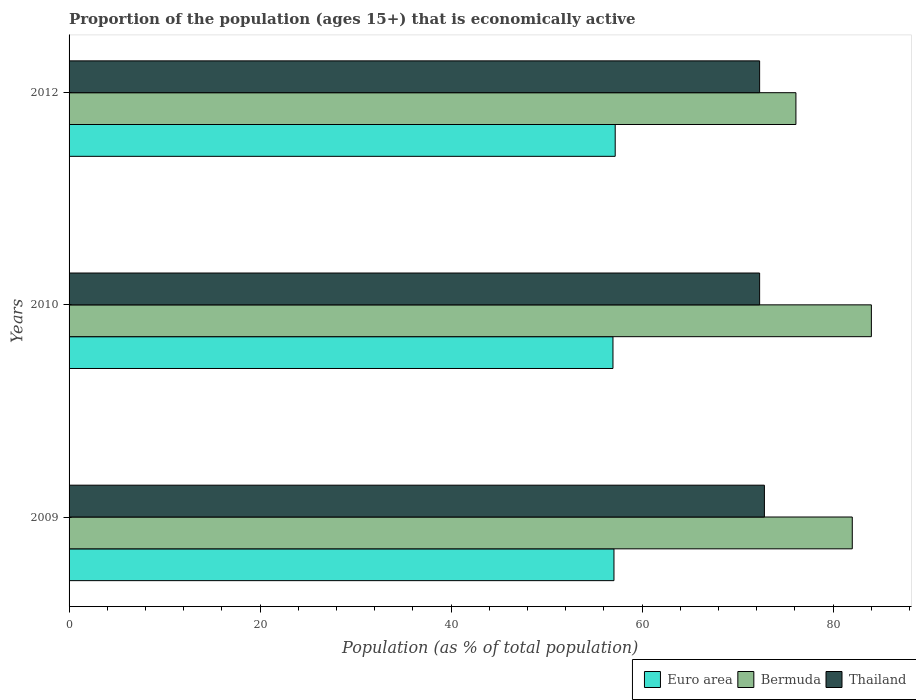Are the number of bars on each tick of the Y-axis equal?
Your response must be concise. Yes. How many bars are there on the 1st tick from the top?
Make the answer very short. 3. In how many cases, is the number of bars for a given year not equal to the number of legend labels?
Provide a succinct answer. 0. What is the proportion of the population that is economically active in Euro area in 2010?
Provide a short and direct response. 56.95. Across all years, what is the maximum proportion of the population that is economically active in Thailand?
Your answer should be compact. 72.8. Across all years, what is the minimum proportion of the population that is economically active in Bermuda?
Keep it short and to the point. 76.1. In which year was the proportion of the population that is economically active in Thailand maximum?
Keep it short and to the point. 2009. In which year was the proportion of the population that is economically active in Thailand minimum?
Your response must be concise. 2010. What is the total proportion of the population that is economically active in Euro area in the graph?
Ensure brevity in your answer.  171.18. What is the difference between the proportion of the population that is economically active in Euro area in 2009 and that in 2010?
Your answer should be very brief. 0.1. What is the difference between the proportion of the population that is economically active in Thailand in 2010 and the proportion of the population that is economically active in Bermuda in 2009?
Keep it short and to the point. -9.7. What is the average proportion of the population that is economically active in Euro area per year?
Provide a succinct answer. 57.06. In the year 2010, what is the difference between the proportion of the population that is economically active in Bermuda and proportion of the population that is economically active in Euro area?
Give a very brief answer. 27.05. In how many years, is the proportion of the population that is economically active in Euro area greater than 68 %?
Offer a terse response. 0. What is the ratio of the proportion of the population that is economically active in Euro area in 2009 to that in 2010?
Provide a short and direct response. 1. Is the proportion of the population that is economically active in Euro area in 2010 less than that in 2012?
Provide a succinct answer. Yes. Is the difference between the proportion of the population that is economically active in Bermuda in 2009 and 2012 greater than the difference between the proportion of the population that is economically active in Euro area in 2009 and 2012?
Offer a very short reply. Yes. What is the difference between the highest and the second highest proportion of the population that is economically active in Thailand?
Offer a terse response. 0.5. What is the difference between the highest and the lowest proportion of the population that is economically active in Thailand?
Your response must be concise. 0.5. Is the sum of the proportion of the population that is economically active in Euro area in 2009 and 2010 greater than the maximum proportion of the population that is economically active in Thailand across all years?
Your answer should be very brief. Yes. What does the 3rd bar from the top in 2009 represents?
Keep it short and to the point. Euro area. What does the 1st bar from the bottom in 2010 represents?
Offer a terse response. Euro area. Are the values on the major ticks of X-axis written in scientific E-notation?
Offer a very short reply. No. Does the graph contain any zero values?
Make the answer very short. No. Does the graph contain grids?
Offer a very short reply. No. How are the legend labels stacked?
Provide a short and direct response. Horizontal. What is the title of the graph?
Offer a very short reply. Proportion of the population (ages 15+) that is economically active. Does "Micronesia" appear as one of the legend labels in the graph?
Offer a very short reply. No. What is the label or title of the X-axis?
Provide a short and direct response. Population (as % of total population). What is the label or title of the Y-axis?
Your response must be concise. Years. What is the Population (as % of total population) in Euro area in 2009?
Your answer should be very brief. 57.05. What is the Population (as % of total population) of Thailand in 2009?
Offer a very short reply. 72.8. What is the Population (as % of total population) of Euro area in 2010?
Provide a succinct answer. 56.95. What is the Population (as % of total population) in Thailand in 2010?
Provide a short and direct response. 72.3. What is the Population (as % of total population) of Euro area in 2012?
Ensure brevity in your answer.  57.18. What is the Population (as % of total population) of Bermuda in 2012?
Give a very brief answer. 76.1. What is the Population (as % of total population) in Thailand in 2012?
Offer a very short reply. 72.3. Across all years, what is the maximum Population (as % of total population) of Euro area?
Make the answer very short. 57.18. Across all years, what is the maximum Population (as % of total population) of Bermuda?
Ensure brevity in your answer.  84. Across all years, what is the maximum Population (as % of total population) of Thailand?
Make the answer very short. 72.8. Across all years, what is the minimum Population (as % of total population) in Euro area?
Provide a succinct answer. 56.95. Across all years, what is the minimum Population (as % of total population) of Bermuda?
Offer a terse response. 76.1. Across all years, what is the minimum Population (as % of total population) in Thailand?
Make the answer very short. 72.3. What is the total Population (as % of total population) in Euro area in the graph?
Your answer should be very brief. 171.18. What is the total Population (as % of total population) in Bermuda in the graph?
Provide a short and direct response. 242.1. What is the total Population (as % of total population) in Thailand in the graph?
Make the answer very short. 217.4. What is the difference between the Population (as % of total population) in Euro area in 2009 and that in 2010?
Offer a very short reply. 0.1. What is the difference between the Population (as % of total population) of Thailand in 2009 and that in 2010?
Your answer should be compact. 0.5. What is the difference between the Population (as % of total population) in Euro area in 2009 and that in 2012?
Offer a terse response. -0.13. What is the difference between the Population (as % of total population) in Bermuda in 2009 and that in 2012?
Provide a succinct answer. 5.9. What is the difference between the Population (as % of total population) in Euro area in 2010 and that in 2012?
Your answer should be compact. -0.23. What is the difference between the Population (as % of total population) in Thailand in 2010 and that in 2012?
Keep it short and to the point. 0. What is the difference between the Population (as % of total population) in Euro area in 2009 and the Population (as % of total population) in Bermuda in 2010?
Your answer should be very brief. -26.95. What is the difference between the Population (as % of total population) of Euro area in 2009 and the Population (as % of total population) of Thailand in 2010?
Give a very brief answer. -15.25. What is the difference between the Population (as % of total population) in Bermuda in 2009 and the Population (as % of total population) in Thailand in 2010?
Your answer should be compact. 9.7. What is the difference between the Population (as % of total population) in Euro area in 2009 and the Population (as % of total population) in Bermuda in 2012?
Make the answer very short. -19.05. What is the difference between the Population (as % of total population) of Euro area in 2009 and the Population (as % of total population) of Thailand in 2012?
Your answer should be compact. -15.25. What is the difference between the Population (as % of total population) of Euro area in 2010 and the Population (as % of total population) of Bermuda in 2012?
Keep it short and to the point. -19.15. What is the difference between the Population (as % of total population) in Euro area in 2010 and the Population (as % of total population) in Thailand in 2012?
Ensure brevity in your answer.  -15.35. What is the average Population (as % of total population) of Euro area per year?
Keep it short and to the point. 57.06. What is the average Population (as % of total population) in Bermuda per year?
Offer a terse response. 80.7. What is the average Population (as % of total population) of Thailand per year?
Keep it short and to the point. 72.47. In the year 2009, what is the difference between the Population (as % of total population) of Euro area and Population (as % of total population) of Bermuda?
Your response must be concise. -24.95. In the year 2009, what is the difference between the Population (as % of total population) of Euro area and Population (as % of total population) of Thailand?
Give a very brief answer. -15.75. In the year 2009, what is the difference between the Population (as % of total population) of Bermuda and Population (as % of total population) of Thailand?
Your answer should be very brief. 9.2. In the year 2010, what is the difference between the Population (as % of total population) of Euro area and Population (as % of total population) of Bermuda?
Make the answer very short. -27.05. In the year 2010, what is the difference between the Population (as % of total population) in Euro area and Population (as % of total population) in Thailand?
Keep it short and to the point. -15.35. In the year 2010, what is the difference between the Population (as % of total population) of Bermuda and Population (as % of total population) of Thailand?
Your answer should be compact. 11.7. In the year 2012, what is the difference between the Population (as % of total population) in Euro area and Population (as % of total population) in Bermuda?
Give a very brief answer. -18.92. In the year 2012, what is the difference between the Population (as % of total population) of Euro area and Population (as % of total population) of Thailand?
Ensure brevity in your answer.  -15.12. What is the ratio of the Population (as % of total population) of Euro area in 2009 to that in 2010?
Give a very brief answer. 1. What is the ratio of the Population (as % of total population) of Bermuda in 2009 to that in 2010?
Give a very brief answer. 0.98. What is the ratio of the Population (as % of total population) in Bermuda in 2009 to that in 2012?
Provide a succinct answer. 1.08. What is the ratio of the Population (as % of total population) of Euro area in 2010 to that in 2012?
Keep it short and to the point. 1. What is the ratio of the Population (as % of total population) in Bermuda in 2010 to that in 2012?
Make the answer very short. 1.1. What is the difference between the highest and the second highest Population (as % of total population) of Euro area?
Your answer should be very brief. 0.13. What is the difference between the highest and the second highest Population (as % of total population) in Bermuda?
Give a very brief answer. 2. What is the difference between the highest and the second highest Population (as % of total population) of Thailand?
Ensure brevity in your answer.  0.5. What is the difference between the highest and the lowest Population (as % of total population) in Euro area?
Offer a terse response. 0.23. What is the difference between the highest and the lowest Population (as % of total population) in Bermuda?
Keep it short and to the point. 7.9. What is the difference between the highest and the lowest Population (as % of total population) of Thailand?
Give a very brief answer. 0.5. 